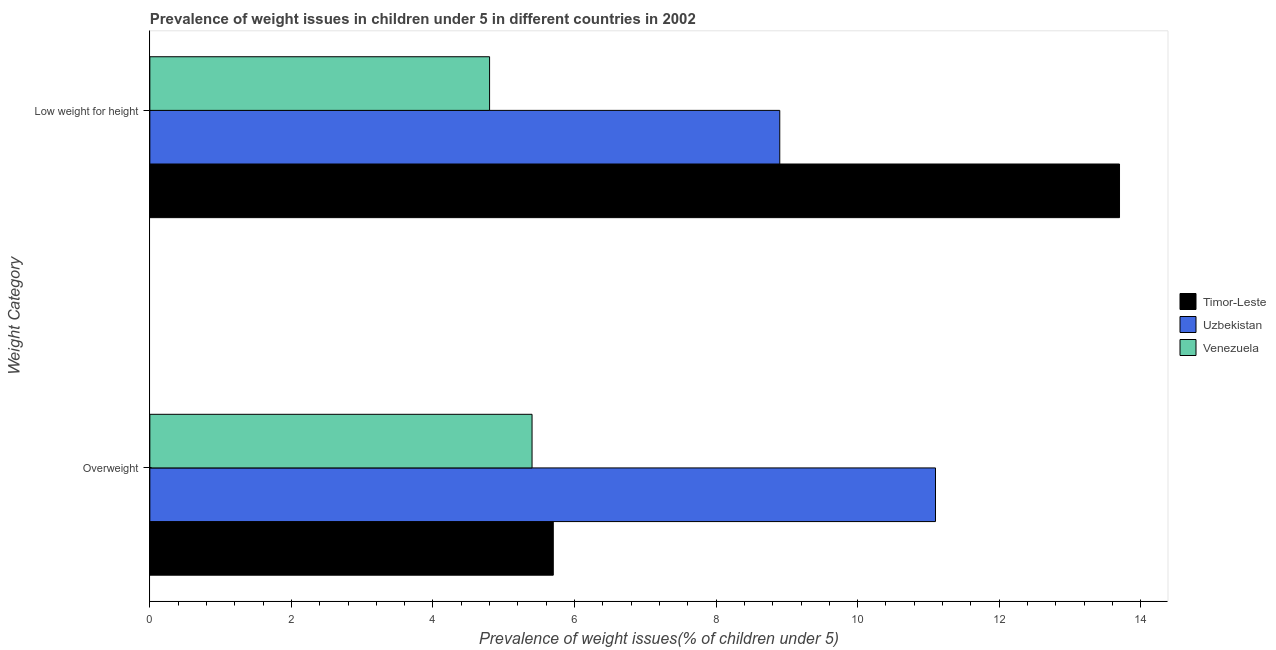Are the number of bars per tick equal to the number of legend labels?
Your answer should be compact. Yes. How many bars are there on the 1st tick from the bottom?
Your answer should be very brief. 3. What is the label of the 2nd group of bars from the top?
Make the answer very short. Overweight. What is the percentage of overweight children in Uzbekistan?
Give a very brief answer. 11.1. Across all countries, what is the maximum percentage of overweight children?
Make the answer very short. 11.1. Across all countries, what is the minimum percentage of underweight children?
Keep it short and to the point. 4.8. In which country was the percentage of overweight children maximum?
Your answer should be very brief. Uzbekistan. In which country was the percentage of overweight children minimum?
Offer a very short reply. Venezuela. What is the total percentage of underweight children in the graph?
Your answer should be very brief. 27.4. What is the difference between the percentage of overweight children in Uzbekistan and that in Venezuela?
Keep it short and to the point. 5.7. What is the difference between the percentage of underweight children in Timor-Leste and the percentage of overweight children in Venezuela?
Give a very brief answer. 8.3. What is the average percentage of underweight children per country?
Provide a succinct answer. 9.13. What is the difference between the percentage of underweight children and percentage of overweight children in Venezuela?
Your answer should be very brief. -0.6. In how many countries, is the percentage of underweight children greater than 10.8 %?
Offer a terse response. 1. What is the ratio of the percentage of underweight children in Venezuela to that in Timor-Leste?
Provide a short and direct response. 0.35. Is the percentage of underweight children in Timor-Leste less than that in Uzbekistan?
Your answer should be compact. No. In how many countries, is the percentage of overweight children greater than the average percentage of overweight children taken over all countries?
Offer a terse response. 1. What does the 1st bar from the top in Overweight represents?
Provide a succinct answer. Venezuela. What does the 2nd bar from the bottom in Overweight represents?
Make the answer very short. Uzbekistan. Are all the bars in the graph horizontal?
Your answer should be very brief. Yes. How many countries are there in the graph?
Keep it short and to the point. 3. What is the difference between two consecutive major ticks on the X-axis?
Provide a short and direct response. 2. Are the values on the major ticks of X-axis written in scientific E-notation?
Provide a succinct answer. No. Does the graph contain any zero values?
Give a very brief answer. No. How many legend labels are there?
Your answer should be very brief. 3. What is the title of the graph?
Offer a terse response. Prevalence of weight issues in children under 5 in different countries in 2002. What is the label or title of the X-axis?
Give a very brief answer. Prevalence of weight issues(% of children under 5). What is the label or title of the Y-axis?
Your answer should be very brief. Weight Category. What is the Prevalence of weight issues(% of children under 5) in Timor-Leste in Overweight?
Provide a succinct answer. 5.7. What is the Prevalence of weight issues(% of children under 5) of Uzbekistan in Overweight?
Keep it short and to the point. 11.1. What is the Prevalence of weight issues(% of children under 5) of Venezuela in Overweight?
Provide a short and direct response. 5.4. What is the Prevalence of weight issues(% of children under 5) of Timor-Leste in Low weight for height?
Your answer should be very brief. 13.7. What is the Prevalence of weight issues(% of children under 5) in Uzbekistan in Low weight for height?
Make the answer very short. 8.9. What is the Prevalence of weight issues(% of children under 5) in Venezuela in Low weight for height?
Make the answer very short. 4.8. Across all Weight Category, what is the maximum Prevalence of weight issues(% of children under 5) in Timor-Leste?
Provide a short and direct response. 13.7. Across all Weight Category, what is the maximum Prevalence of weight issues(% of children under 5) of Uzbekistan?
Give a very brief answer. 11.1. Across all Weight Category, what is the maximum Prevalence of weight issues(% of children under 5) in Venezuela?
Provide a short and direct response. 5.4. Across all Weight Category, what is the minimum Prevalence of weight issues(% of children under 5) of Timor-Leste?
Offer a very short reply. 5.7. Across all Weight Category, what is the minimum Prevalence of weight issues(% of children under 5) in Uzbekistan?
Provide a succinct answer. 8.9. Across all Weight Category, what is the minimum Prevalence of weight issues(% of children under 5) of Venezuela?
Give a very brief answer. 4.8. What is the total Prevalence of weight issues(% of children under 5) of Venezuela in the graph?
Keep it short and to the point. 10.2. What is the difference between the Prevalence of weight issues(% of children under 5) of Timor-Leste in Overweight and that in Low weight for height?
Provide a short and direct response. -8. What is the difference between the Prevalence of weight issues(% of children under 5) in Uzbekistan in Overweight and that in Low weight for height?
Keep it short and to the point. 2.2. What is the difference between the Prevalence of weight issues(% of children under 5) of Venezuela in Overweight and that in Low weight for height?
Ensure brevity in your answer.  0.6. What is the average Prevalence of weight issues(% of children under 5) of Timor-Leste per Weight Category?
Ensure brevity in your answer.  9.7. What is the average Prevalence of weight issues(% of children under 5) of Venezuela per Weight Category?
Your answer should be very brief. 5.1. What is the difference between the Prevalence of weight issues(% of children under 5) of Uzbekistan and Prevalence of weight issues(% of children under 5) of Venezuela in Overweight?
Your response must be concise. 5.7. What is the difference between the Prevalence of weight issues(% of children under 5) in Timor-Leste and Prevalence of weight issues(% of children under 5) in Uzbekistan in Low weight for height?
Your answer should be very brief. 4.8. What is the difference between the Prevalence of weight issues(% of children under 5) of Uzbekistan and Prevalence of weight issues(% of children under 5) of Venezuela in Low weight for height?
Your answer should be compact. 4.1. What is the ratio of the Prevalence of weight issues(% of children under 5) of Timor-Leste in Overweight to that in Low weight for height?
Make the answer very short. 0.42. What is the ratio of the Prevalence of weight issues(% of children under 5) of Uzbekistan in Overweight to that in Low weight for height?
Keep it short and to the point. 1.25. What is the ratio of the Prevalence of weight issues(% of children under 5) of Venezuela in Overweight to that in Low weight for height?
Your answer should be very brief. 1.12. What is the difference between the highest and the second highest Prevalence of weight issues(% of children under 5) of Timor-Leste?
Your response must be concise. 8. What is the difference between the highest and the lowest Prevalence of weight issues(% of children under 5) of Timor-Leste?
Ensure brevity in your answer.  8. What is the difference between the highest and the lowest Prevalence of weight issues(% of children under 5) in Venezuela?
Your response must be concise. 0.6. 